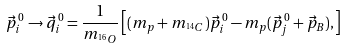Convert formula to latex. <formula><loc_0><loc_0><loc_500><loc_500>\vec { p } ^ { \, 0 } _ { i } \rightarrow \vec { q } ^ { \, 0 } _ { i } = \frac { 1 } { m _ { ^ { 1 6 } O } } \left [ ( m _ { p } + m _ { ^ { 1 4 } C } ) \vec { p } ^ { \, 0 } _ { i } - m _ { p } ( \vec { p } ^ { \, 0 } _ { j } + \vec { p } _ { B } ) , \right ]</formula> 